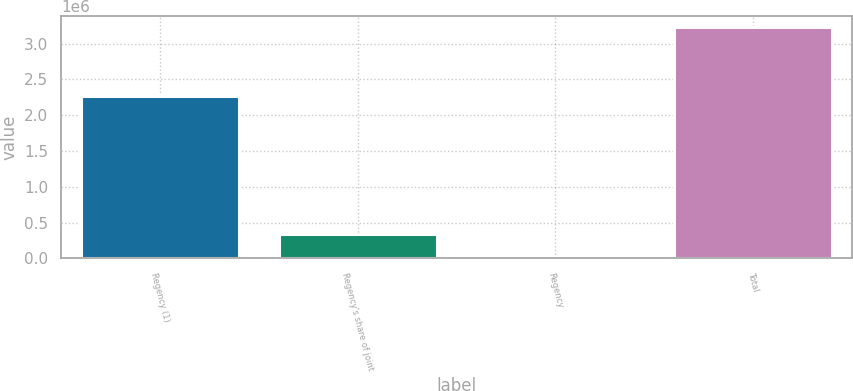<chart> <loc_0><loc_0><loc_500><loc_500><bar_chart><fcel>Regency (1)<fcel>Regency's share of joint<fcel>Regency<fcel>Total<nl><fcel>2.27465e+06<fcel>343943<fcel>23428<fcel>3.22858e+06<nl></chart> 